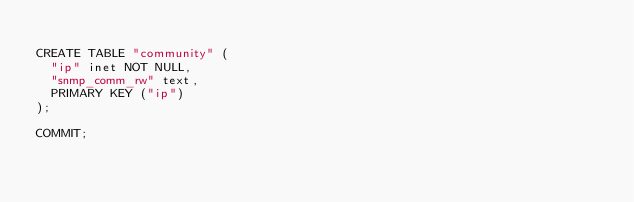<code> <loc_0><loc_0><loc_500><loc_500><_SQL_>
CREATE TABLE "community" (
  "ip" inet NOT NULL,
  "snmp_comm_rw" text,
  PRIMARY KEY ("ip")
);

COMMIT;
</code> 